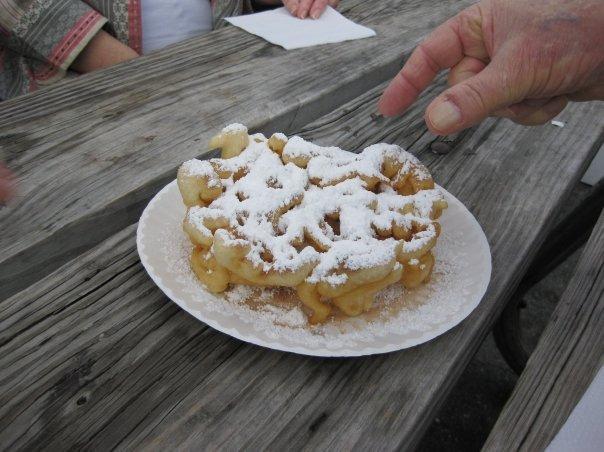How many people are there?
Give a very brief answer. 2. How many giraffe are standing near the zebra?
Give a very brief answer. 0. 